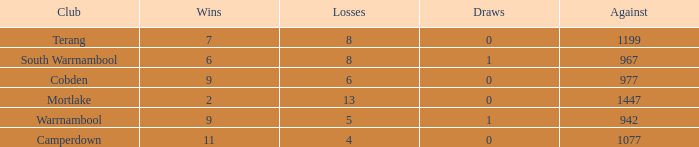What's the number of losses when the wins were more than 11 and had 0 draws? 0.0. Would you be able to parse every entry in this table? {'header': ['Club', 'Wins', 'Losses', 'Draws', 'Against'], 'rows': [['Terang', '7', '8', '0', '1199'], ['South Warrnambool', '6', '8', '1', '967'], ['Cobden', '9', '6', '0', '977'], ['Mortlake', '2', '13', '0', '1447'], ['Warrnambool', '9', '5', '1', '942'], ['Camperdown', '11', '4', '0', '1077']]} 